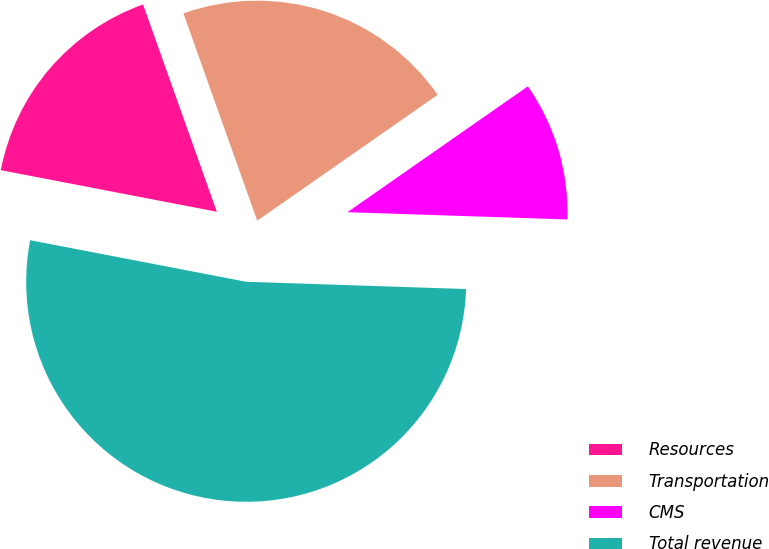Convert chart. <chart><loc_0><loc_0><loc_500><loc_500><pie_chart><fcel>Resources<fcel>Transportation<fcel>CMS<fcel>Total revenue<nl><fcel>16.53%<fcel>20.75%<fcel>10.22%<fcel>52.5%<nl></chart> 